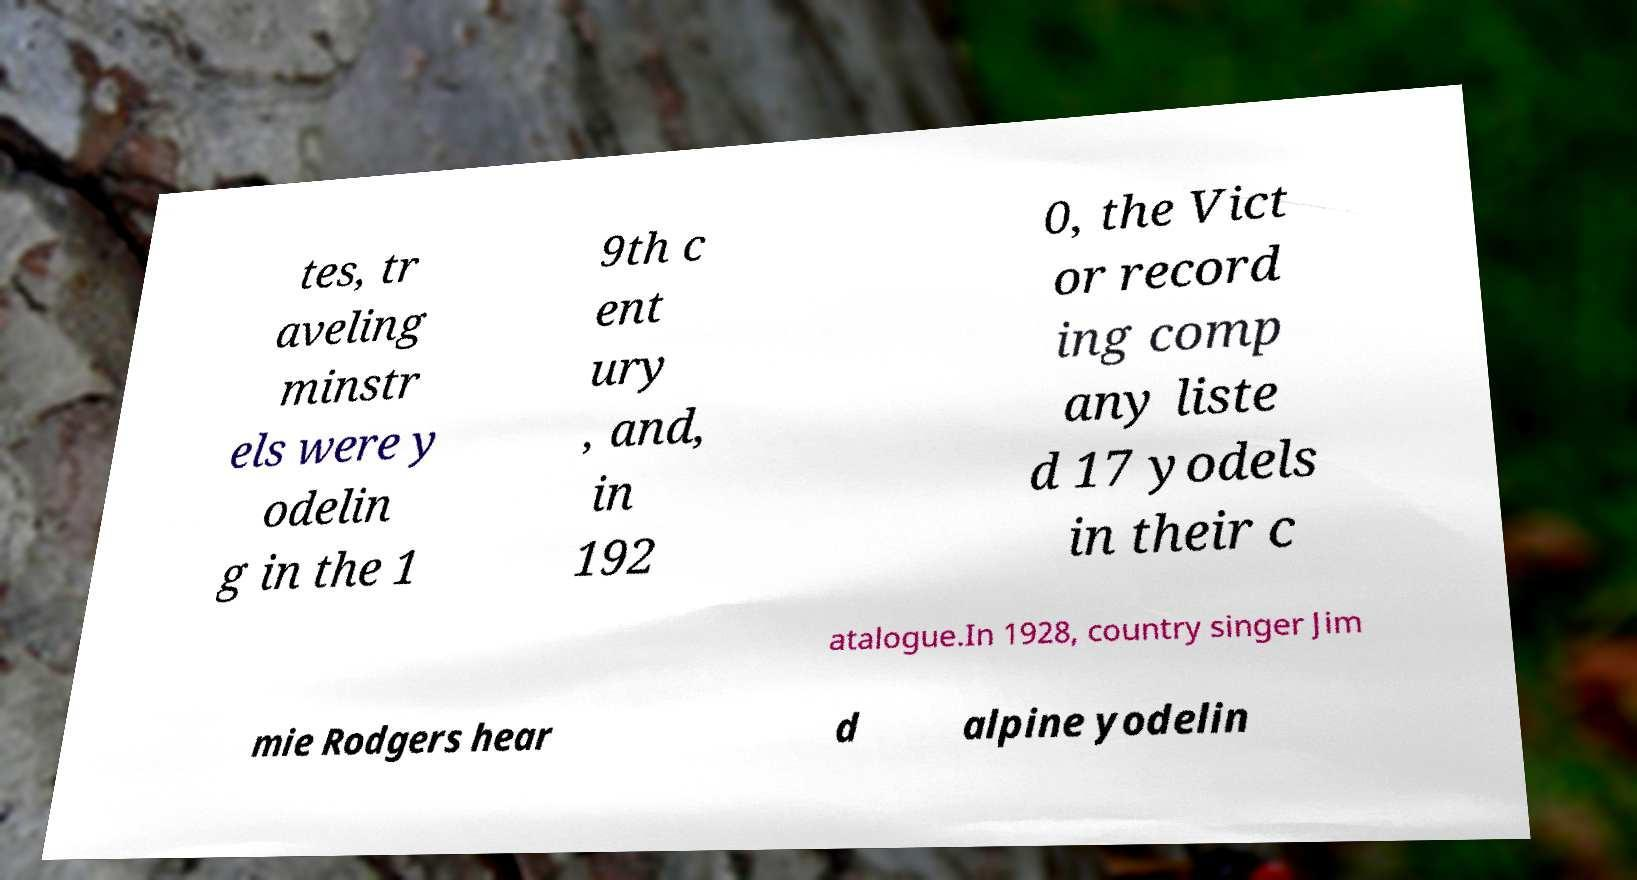Please identify and transcribe the text found in this image. tes, tr aveling minstr els were y odelin g in the 1 9th c ent ury , and, in 192 0, the Vict or record ing comp any liste d 17 yodels in their c atalogue.In 1928, country singer Jim mie Rodgers hear d alpine yodelin 